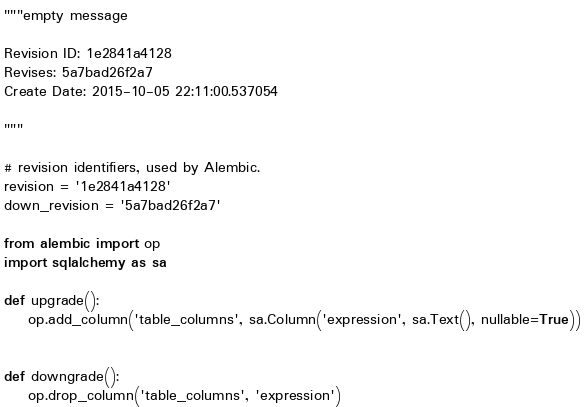<code> <loc_0><loc_0><loc_500><loc_500><_Python_>"""empty message

Revision ID: 1e2841a4128
Revises: 5a7bad26f2a7
Create Date: 2015-10-05 22:11:00.537054

"""

# revision identifiers, used by Alembic.
revision = '1e2841a4128'
down_revision = '5a7bad26f2a7'

from alembic import op
import sqlalchemy as sa

def upgrade():
    op.add_column('table_columns', sa.Column('expression', sa.Text(), nullable=True))


def downgrade():
    op.drop_column('table_columns', 'expression')
</code> 